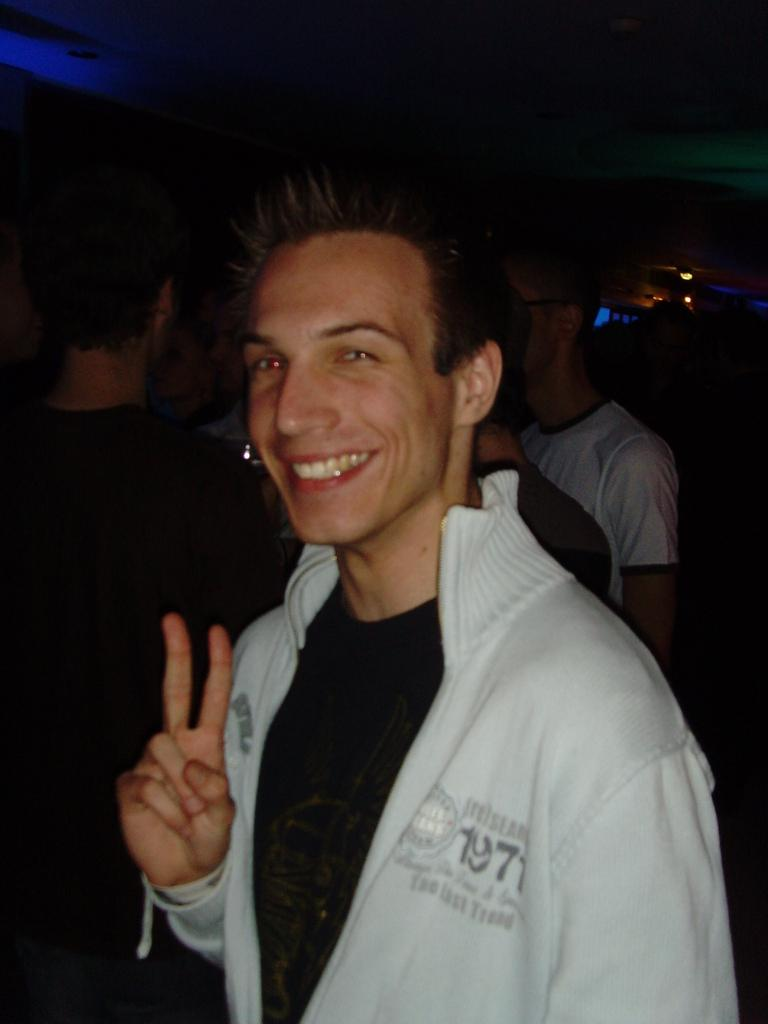Who is present in the image? There is a man in the image. What is the man's facial expression? The man is smiling. Can you describe the people in the background of the image? There are people standing in the background of the image. What can be seen in the image besides the people? There are lights visible in the image. How would you describe the overall lighting in the image? The background of the image is dark. What type of mitten is the man wearing in the image? The man is not wearing a mitten in the image. Can you see any ants crawling on the people in the background? There are no ants visible in the image. 